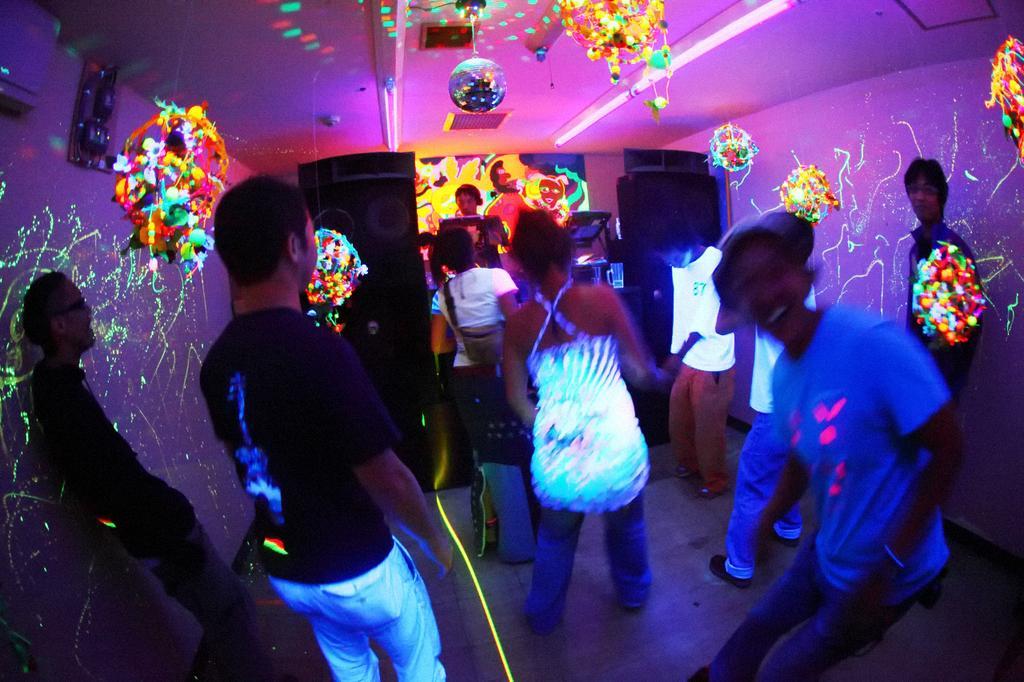How would you summarize this image in a sentence or two? In this picture there are people in the image, there are colorful lights around the image, there are speakers in the image. 